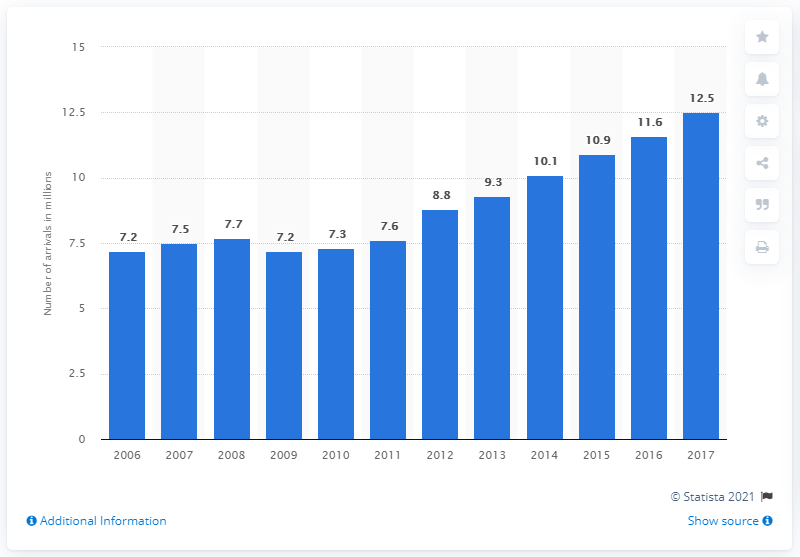Outline some significant characteristics in this image. In 2017, a total of 12.5 tourists arrived at accommodation establishments in Hungary. 